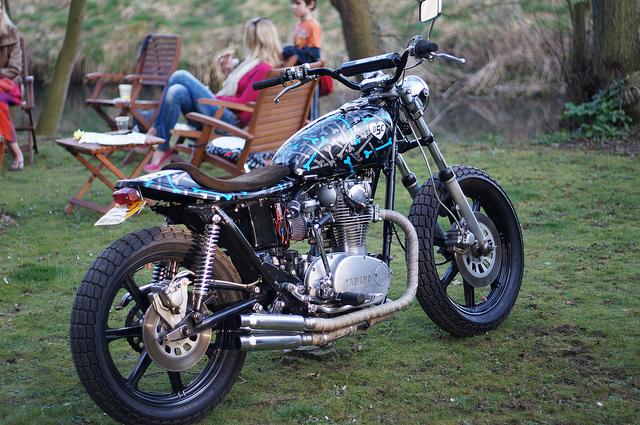Has the motorbike been painted?
Write a very short answer. Yes. What is the name of this vehicle?
Keep it brief. Motorcycle. Is there a face shield on the motorcycle?
Be succinct. No. Can the person in the orange shirt operate this vehicle legally?
Be succinct. No. 